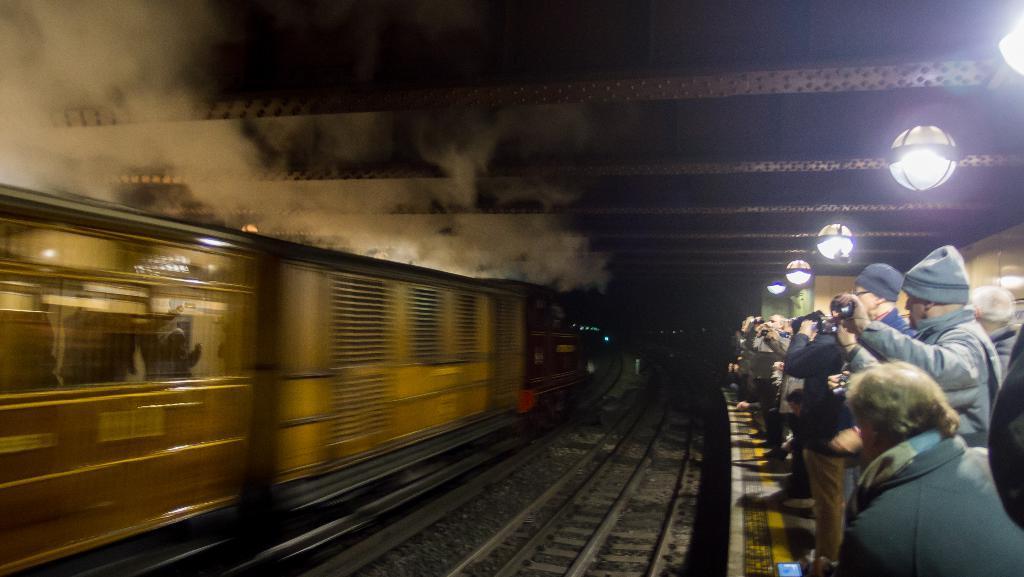In one or two sentences, can you explain what this image depicts? In this picture we can see some people are standing on a railway platform, at the bottom we can see railway tracks, on the left side there is a train, we can see some lights on the right side, there is smoke at the left top of the picture. 